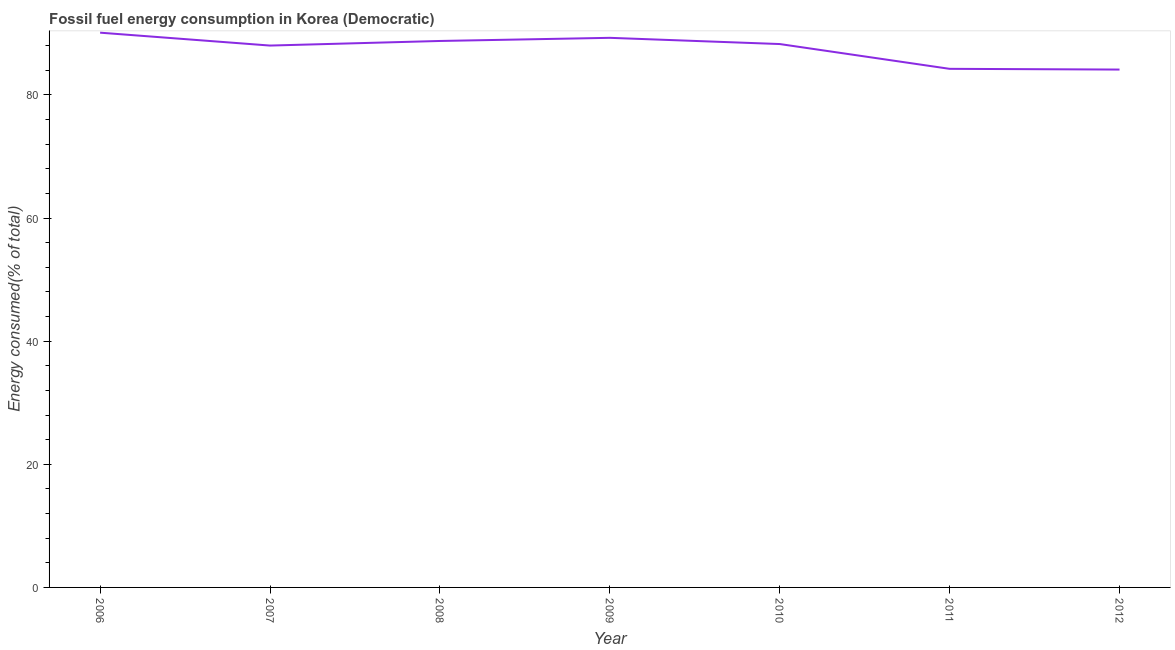What is the fossil fuel energy consumption in 2008?
Your response must be concise. 88.77. Across all years, what is the maximum fossil fuel energy consumption?
Your answer should be very brief. 90.11. Across all years, what is the minimum fossil fuel energy consumption?
Give a very brief answer. 84.12. In which year was the fossil fuel energy consumption maximum?
Your response must be concise. 2006. In which year was the fossil fuel energy consumption minimum?
Offer a very short reply. 2012. What is the sum of the fossil fuel energy consumption?
Give a very brief answer. 612.8. What is the difference between the fossil fuel energy consumption in 2006 and 2011?
Ensure brevity in your answer.  5.87. What is the average fossil fuel energy consumption per year?
Your response must be concise. 87.54. What is the median fossil fuel energy consumption?
Your answer should be very brief. 88.27. In how many years, is the fossil fuel energy consumption greater than 40 %?
Your response must be concise. 7. Do a majority of the years between 2009 and 2011 (inclusive) have fossil fuel energy consumption greater than 52 %?
Give a very brief answer. Yes. What is the ratio of the fossil fuel energy consumption in 2009 to that in 2012?
Your answer should be very brief. 1.06. What is the difference between the highest and the second highest fossil fuel energy consumption?
Your answer should be very brief. 0.84. Is the sum of the fossil fuel energy consumption in 2009 and 2010 greater than the maximum fossil fuel energy consumption across all years?
Provide a short and direct response. Yes. What is the difference between the highest and the lowest fossil fuel energy consumption?
Provide a short and direct response. 5.99. In how many years, is the fossil fuel energy consumption greater than the average fossil fuel energy consumption taken over all years?
Your answer should be compact. 5. Does the fossil fuel energy consumption monotonically increase over the years?
Provide a succinct answer. No. How many years are there in the graph?
Your response must be concise. 7. What is the difference between two consecutive major ticks on the Y-axis?
Make the answer very short. 20. Are the values on the major ticks of Y-axis written in scientific E-notation?
Offer a terse response. No. Does the graph contain any zero values?
Provide a succinct answer. No. Does the graph contain grids?
Ensure brevity in your answer.  No. What is the title of the graph?
Offer a terse response. Fossil fuel energy consumption in Korea (Democratic). What is the label or title of the X-axis?
Offer a very short reply. Year. What is the label or title of the Y-axis?
Your answer should be compact. Energy consumed(% of total). What is the Energy consumed(% of total) of 2006?
Your answer should be very brief. 90.11. What is the Energy consumed(% of total) in 2007?
Keep it short and to the point. 88.02. What is the Energy consumed(% of total) of 2008?
Offer a very short reply. 88.77. What is the Energy consumed(% of total) of 2009?
Provide a short and direct response. 89.28. What is the Energy consumed(% of total) in 2010?
Offer a very short reply. 88.27. What is the Energy consumed(% of total) of 2011?
Offer a terse response. 84.24. What is the Energy consumed(% of total) of 2012?
Offer a terse response. 84.12. What is the difference between the Energy consumed(% of total) in 2006 and 2007?
Your answer should be very brief. 2.09. What is the difference between the Energy consumed(% of total) in 2006 and 2008?
Offer a very short reply. 1.35. What is the difference between the Energy consumed(% of total) in 2006 and 2009?
Your answer should be very brief. 0.84. What is the difference between the Energy consumed(% of total) in 2006 and 2010?
Offer a terse response. 1.85. What is the difference between the Energy consumed(% of total) in 2006 and 2011?
Provide a succinct answer. 5.87. What is the difference between the Energy consumed(% of total) in 2006 and 2012?
Offer a terse response. 5.99. What is the difference between the Energy consumed(% of total) in 2007 and 2008?
Keep it short and to the point. -0.75. What is the difference between the Energy consumed(% of total) in 2007 and 2009?
Make the answer very short. -1.26. What is the difference between the Energy consumed(% of total) in 2007 and 2010?
Offer a very short reply. -0.25. What is the difference between the Energy consumed(% of total) in 2007 and 2011?
Offer a very short reply. 3.78. What is the difference between the Energy consumed(% of total) in 2007 and 2012?
Your answer should be very brief. 3.9. What is the difference between the Energy consumed(% of total) in 2008 and 2009?
Provide a succinct answer. -0.51. What is the difference between the Energy consumed(% of total) in 2008 and 2010?
Provide a succinct answer. 0.5. What is the difference between the Energy consumed(% of total) in 2008 and 2011?
Offer a very short reply. 4.53. What is the difference between the Energy consumed(% of total) in 2008 and 2012?
Your answer should be compact. 4.65. What is the difference between the Energy consumed(% of total) in 2009 and 2010?
Keep it short and to the point. 1.01. What is the difference between the Energy consumed(% of total) in 2009 and 2011?
Keep it short and to the point. 5.04. What is the difference between the Energy consumed(% of total) in 2009 and 2012?
Provide a short and direct response. 5.16. What is the difference between the Energy consumed(% of total) in 2010 and 2011?
Offer a terse response. 4.03. What is the difference between the Energy consumed(% of total) in 2010 and 2012?
Make the answer very short. 4.15. What is the difference between the Energy consumed(% of total) in 2011 and 2012?
Your answer should be very brief. 0.12. What is the ratio of the Energy consumed(% of total) in 2006 to that in 2008?
Provide a succinct answer. 1.01. What is the ratio of the Energy consumed(% of total) in 2006 to that in 2009?
Offer a very short reply. 1.01. What is the ratio of the Energy consumed(% of total) in 2006 to that in 2010?
Offer a very short reply. 1.02. What is the ratio of the Energy consumed(% of total) in 2006 to that in 2011?
Provide a succinct answer. 1.07. What is the ratio of the Energy consumed(% of total) in 2006 to that in 2012?
Your answer should be compact. 1.07. What is the ratio of the Energy consumed(% of total) in 2007 to that in 2008?
Ensure brevity in your answer.  0.99. What is the ratio of the Energy consumed(% of total) in 2007 to that in 2009?
Your response must be concise. 0.99. What is the ratio of the Energy consumed(% of total) in 2007 to that in 2011?
Give a very brief answer. 1.04. What is the ratio of the Energy consumed(% of total) in 2007 to that in 2012?
Offer a terse response. 1.05. What is the ratio of the Energy consumed(% of total) in 2008 to that in 2011?
Offer a very short reply. 1.05. What is the ratio of the Energy consumed(% of total) in 2008 to that in 2012?
Your answer should be very brief. 1.05. What is the ratio of the Energy consumed(% of total) in 2009 to that in 2011?
Your answer should be compact. 1.06. What is the ratio of the Energy consumed(% of total) in 2009 to that in 2012?
Your answer should be compact. 1.06. What is the ratio of the Energy consumed(% of total) in 2010 to that in 2011?
Ensure brevity in your answer.  1.05. What is the ratio of the Energy consumed(% of total) in 2010 to that in 2012?
Ensure brevity in your answer.  1.05. 